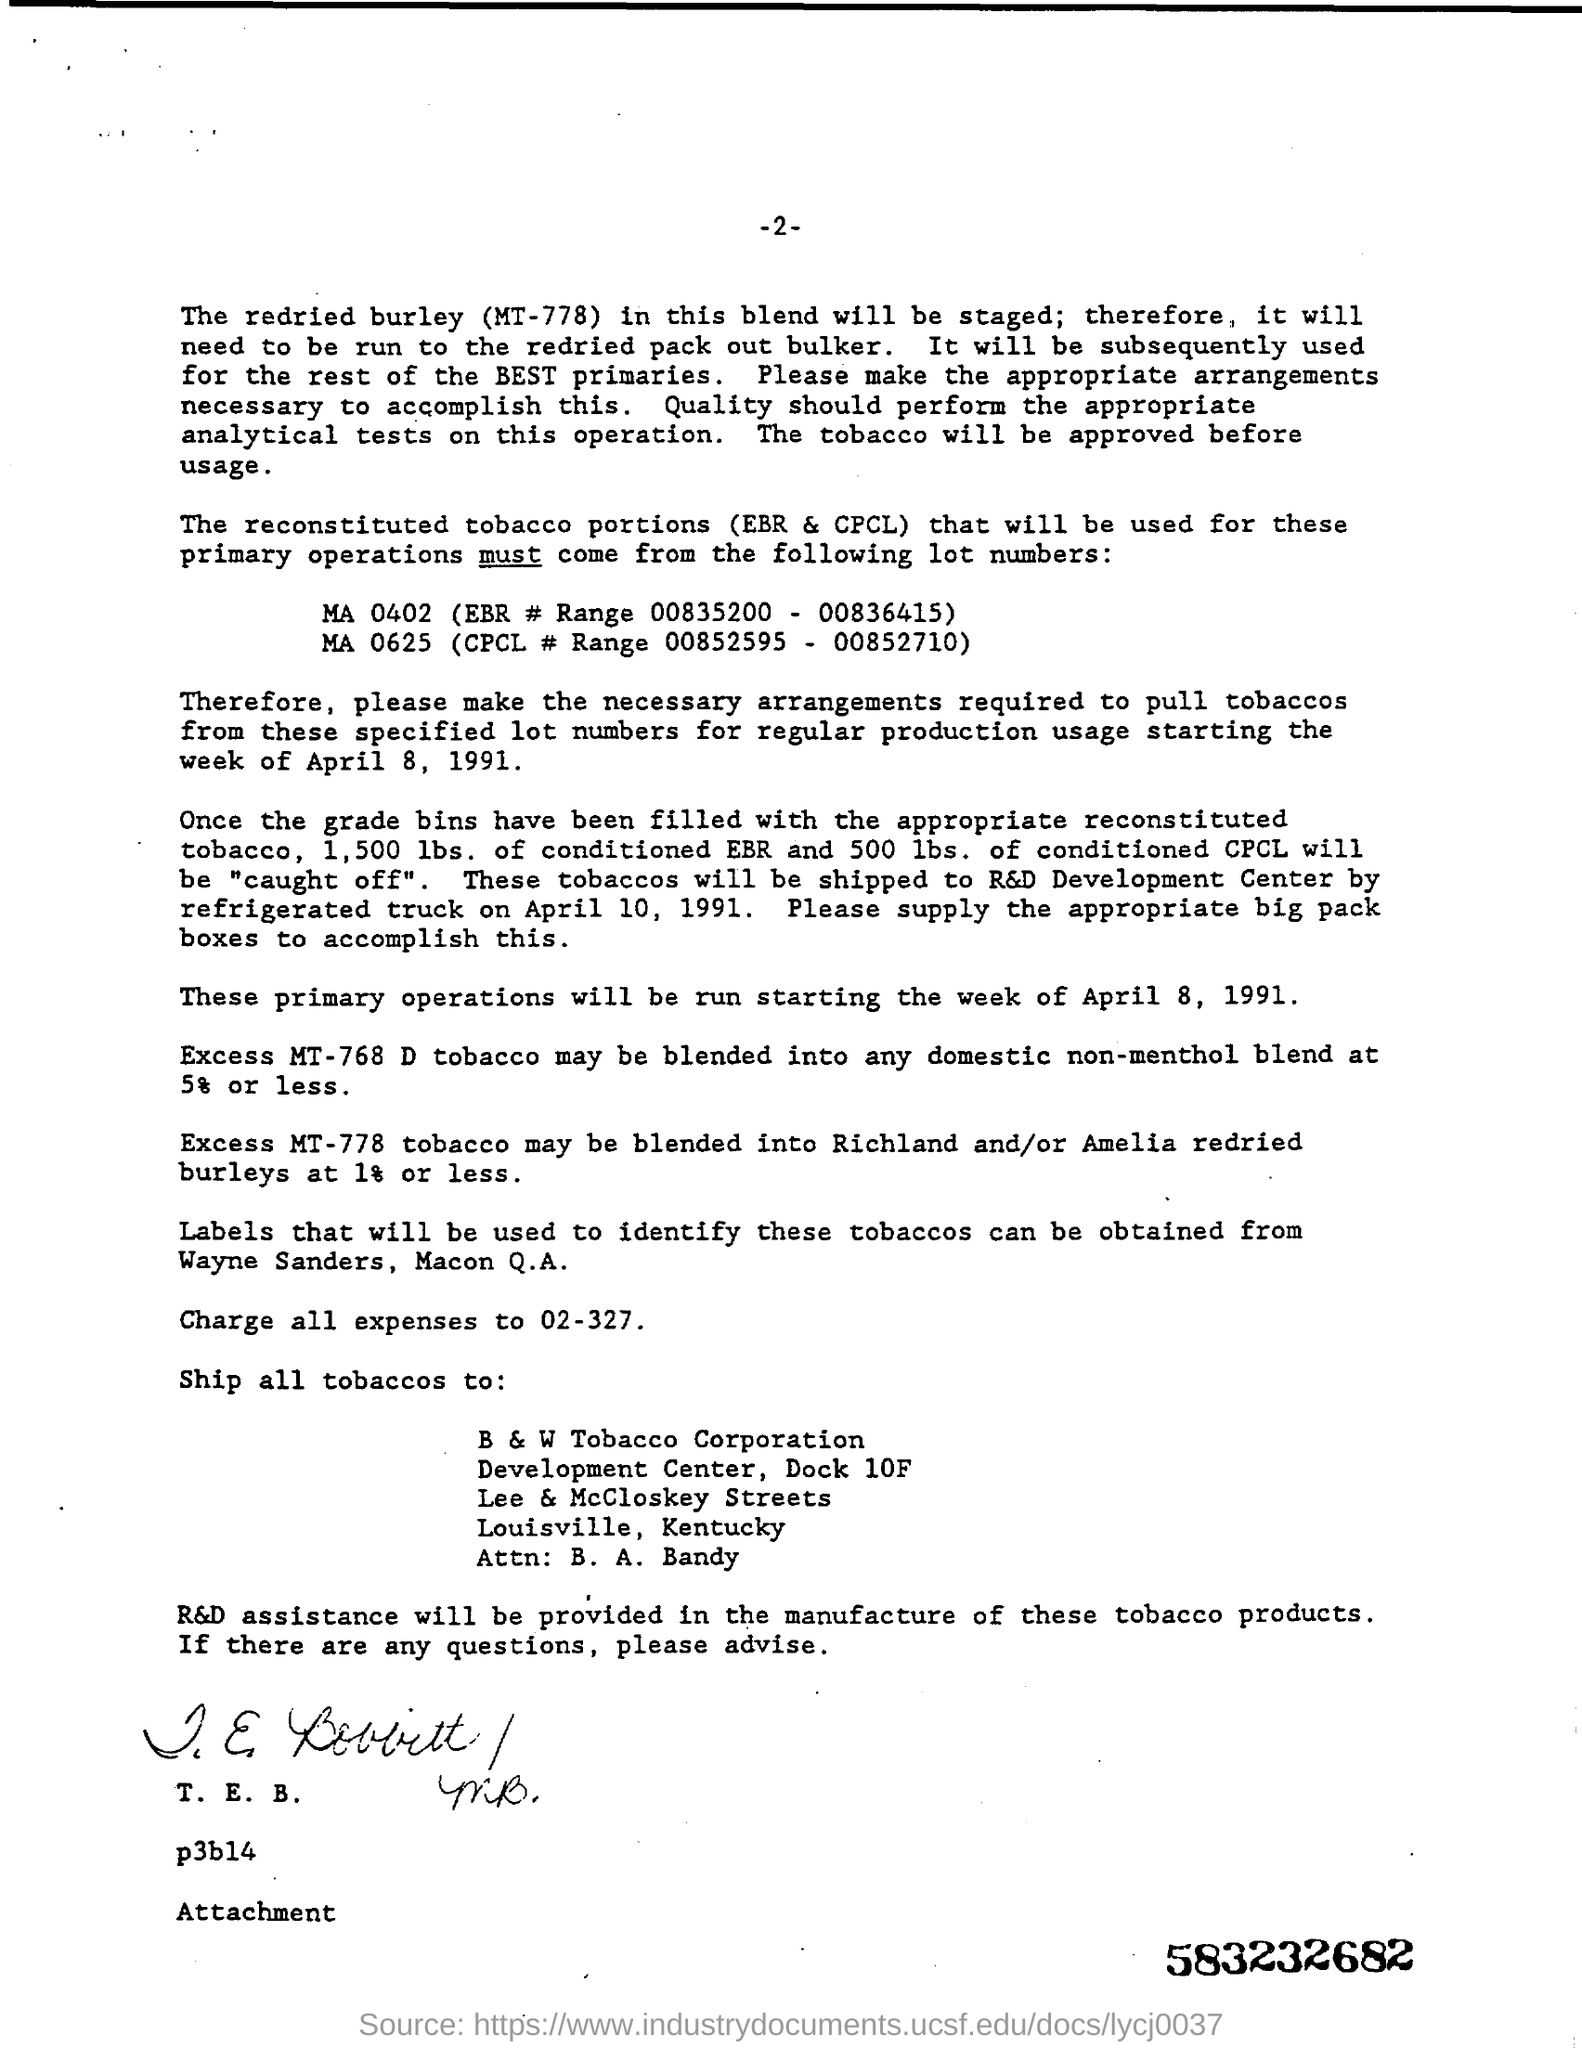Draw attention to some important aspects in this diagram. The source of labels for identifying the tobacco discussed in this text is unknown. The assistance of R&D will be provided in the manufacture of these tobacco products. The tobacco is being shipped to B & W Tobacco Corporation. 